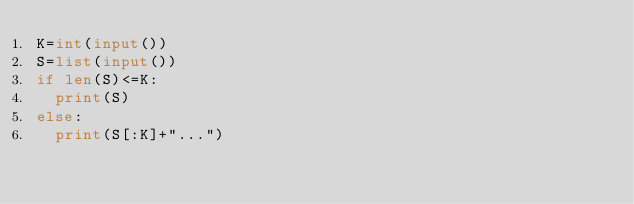Convert code to text. <code><loc_0><loc_0><loc_500><loc_500><_Python_>K=int(input())
S=list(input())
if len(S)<=K:
  print(S)
else:
  print(S[:K]+"...")</code> 